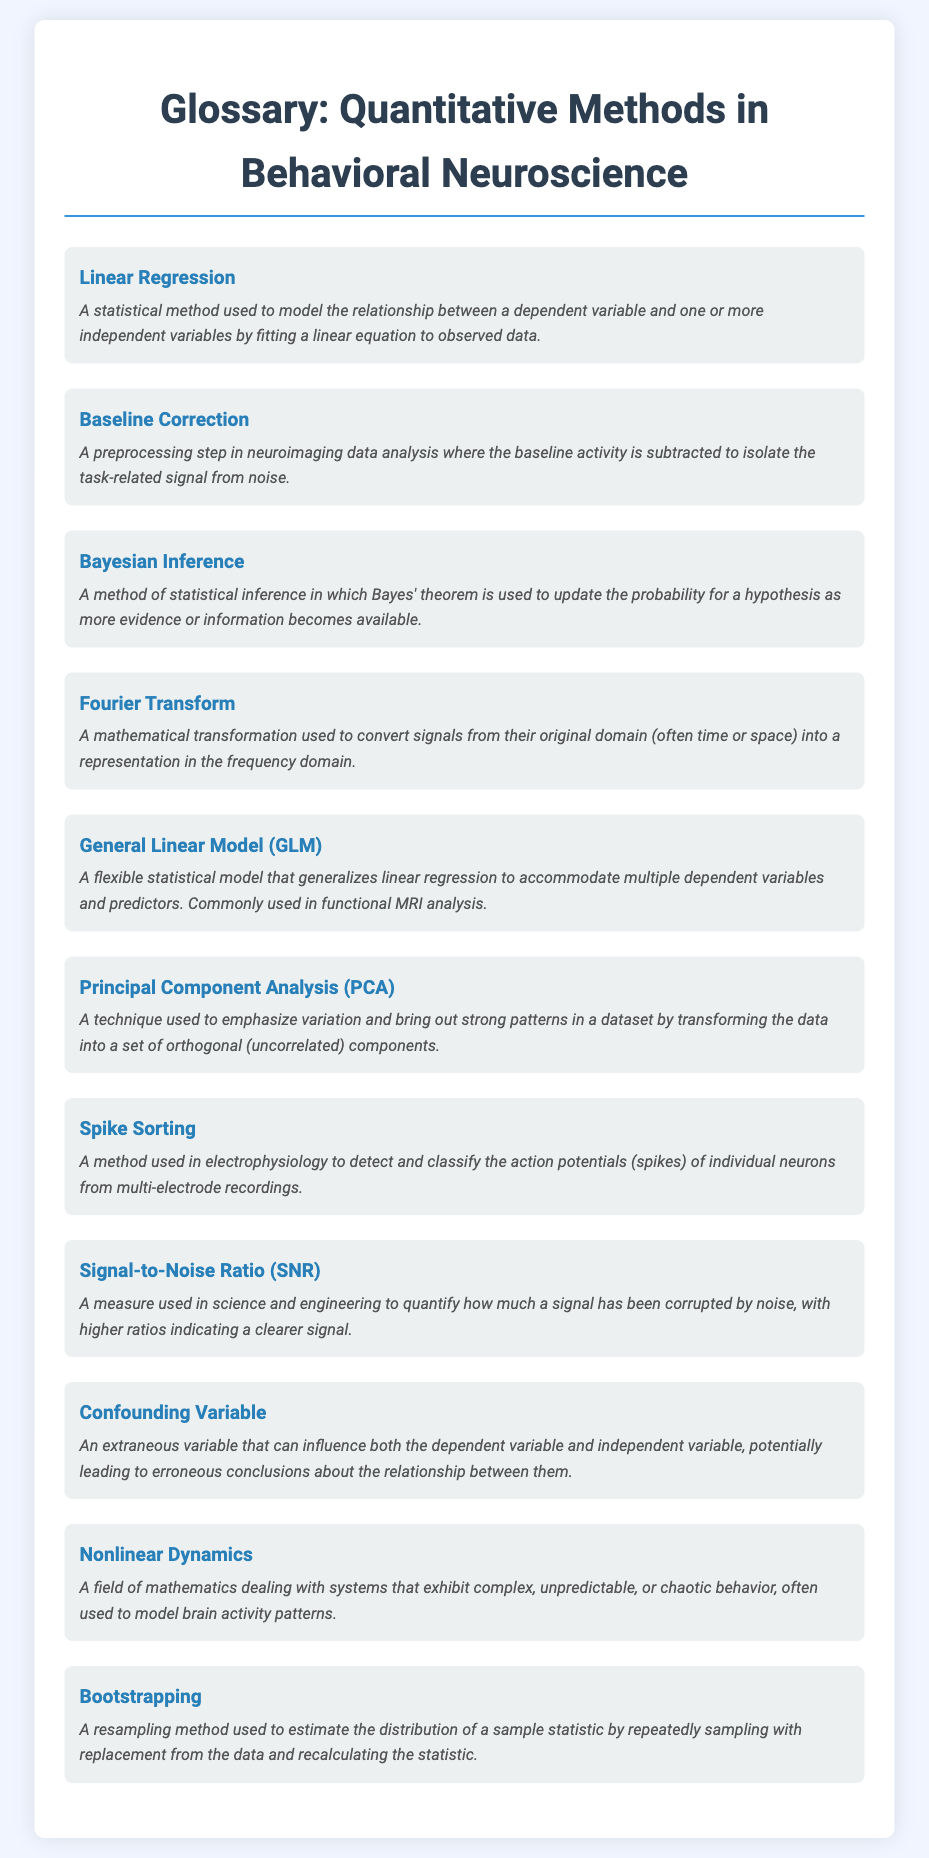What is the term for a statistical method modeling relationships between variables? The document defines a term specifically representing this concept, which is mentioned in the introduction to linear regression.
Answer: Linear Regression What is the meaning of Baseline Correction in neuroimaging? The document describes this term as a preprocessing step to isolate task-related signals in neuroimaging data analysis.
Answer: A preprocessing step What does the acronym GLM stand for? The document uses this acronym to refer to the general statistical model mentioned multiple times throughout the text.
Answer: General Linear Model What technique brings out strong patterns in a dataset by transforming data? The document defines this technique, which emphasizes variation and is connected to data analysis in neuroscience.
Answer: Principal Component Analysis What does SNR stand for, as mentioned in the glossary? The document describes this as a measure of signal clarity in relation to noise, defined in the context of science and engineering.
Answer: Signal-to-Noise Ratio How many specific methods or terms are defined in the glossary section? The document contains a list of distinct terms presented under the glossary section related to quantitative methods.
Answer: Ten Which term describes the method of classifying action potentials from neuronal recordings? The document outlines a specific method that helps in analyzing electrophysiology data, hinting towards its relevance in neuroscience.
Answer: Spike Sorting What is the purpose of Bootstrapping as per the glossary? The document states that this method estimates the distribution of a statistic by repeatedly sampling from data.
Answer: A resampling method Which type of analysis commonly utilizes the General Linear Model? The document indicates a specific area within neuroscience where this model is frequently applied.
Answer: Functional MRI analysis 